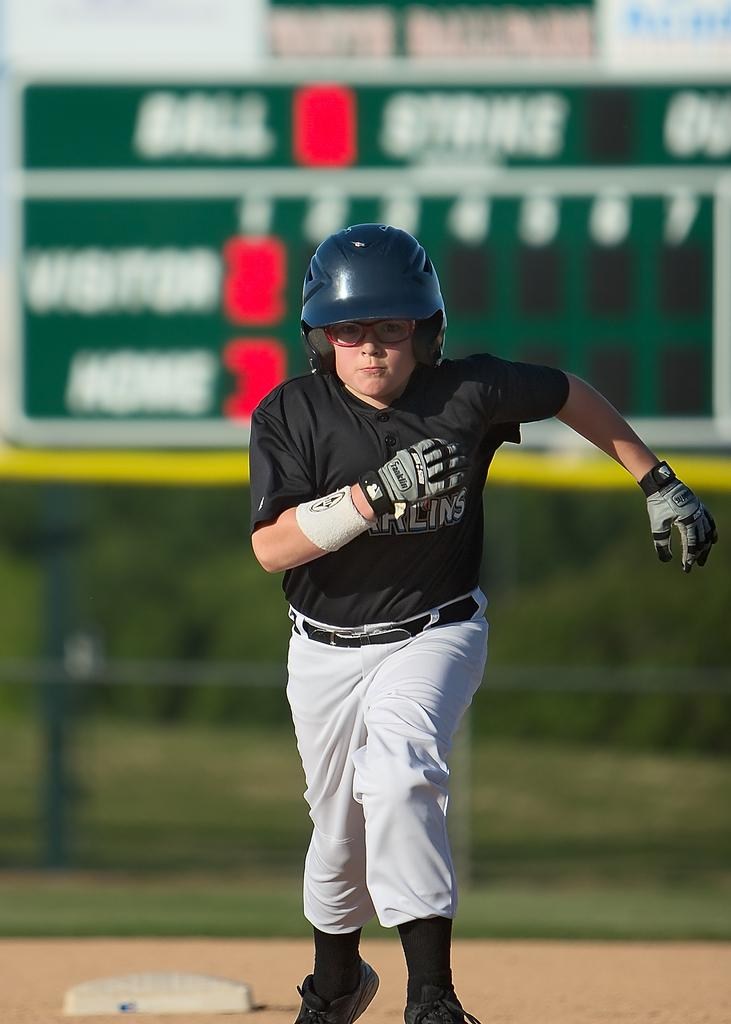Provide a one-sentence caption for the provided image. A young man with glasses runs the bases wearing a batting helmet and Franklin gloves. 